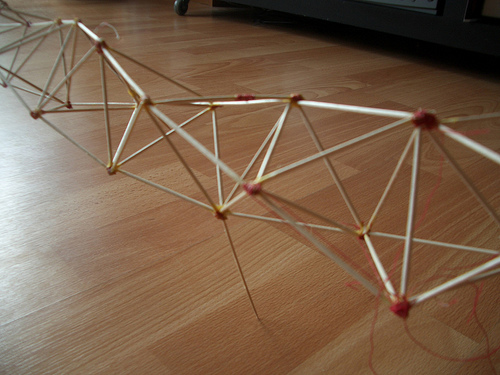<image>
Is the stick to the left of the stick? No. The stick is not to the left of the stick. From this viewpoint, they have a different horizontal relationship. 